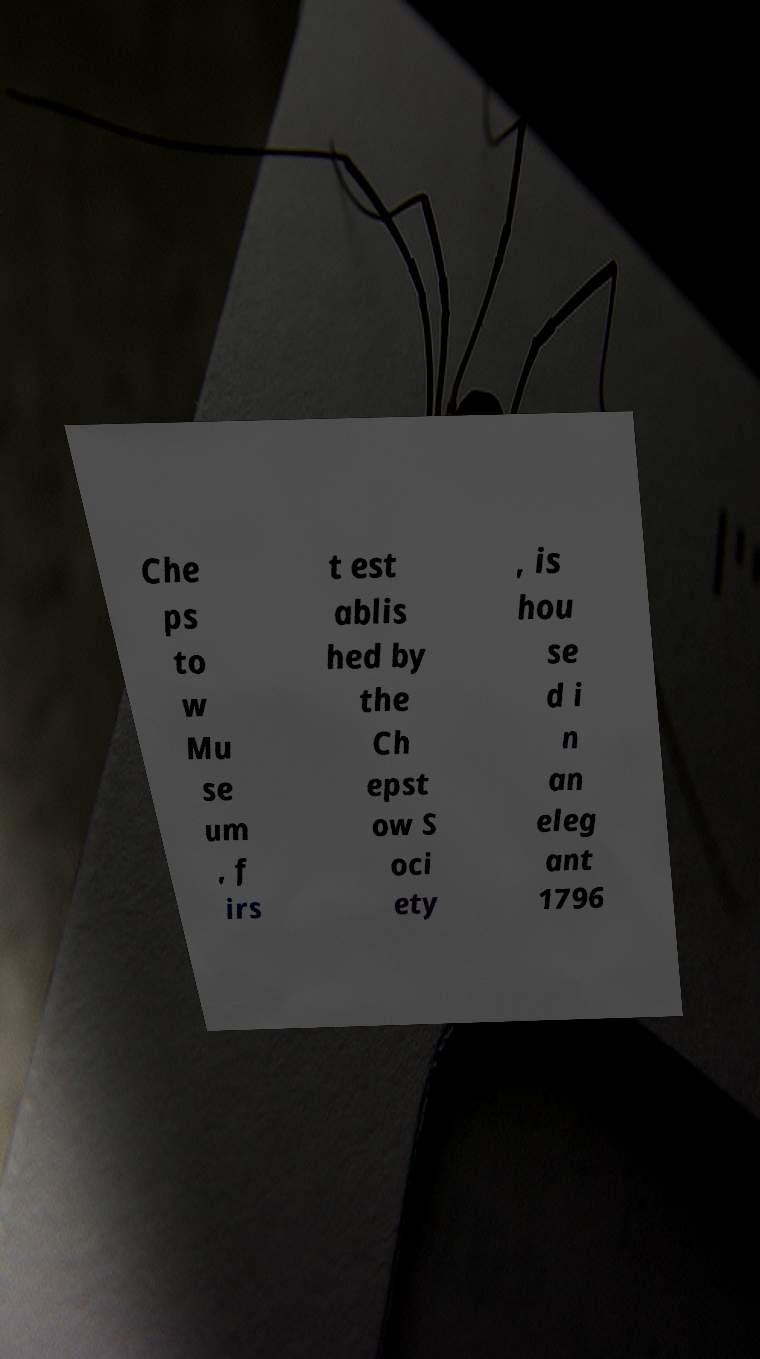What messages or text are displayed in this image? I need them in a readable, typed format. Che ps to w Mu se um , f irs t est ablis hed by the Ch epst ow S oci ety , is hou se d i n an eleg ant 1796 